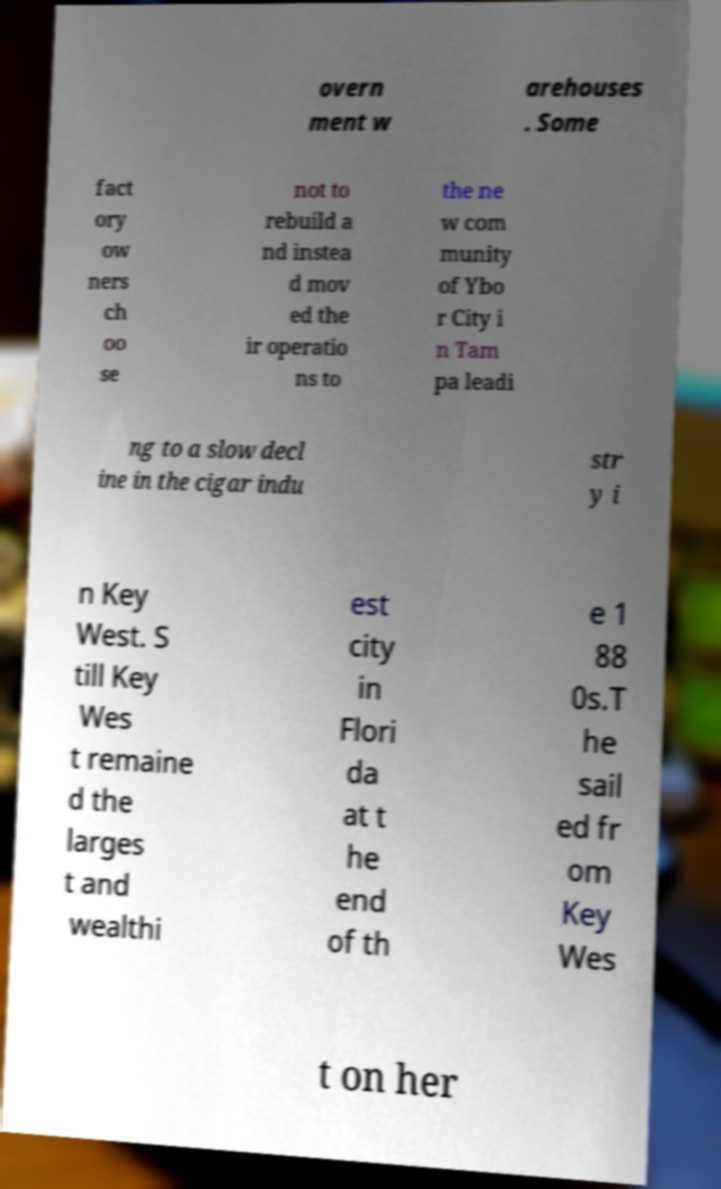Could you extract and type out the text from this image? overn ment w arehouses . Some fact ory ow ners ch oo se not to rebuild a nd instea d mov ed the ir operatio ns to the ne w com munity of Ybo r City i n Tam pa leadi ng to a slow decl ine in the cigar indu str y i n Key West. S till Key Wes t remaine d the larges t and wealthi est city in Flori da at t he end of th e 1 88 0s.T he sail ed fr om Key Wes t on her 